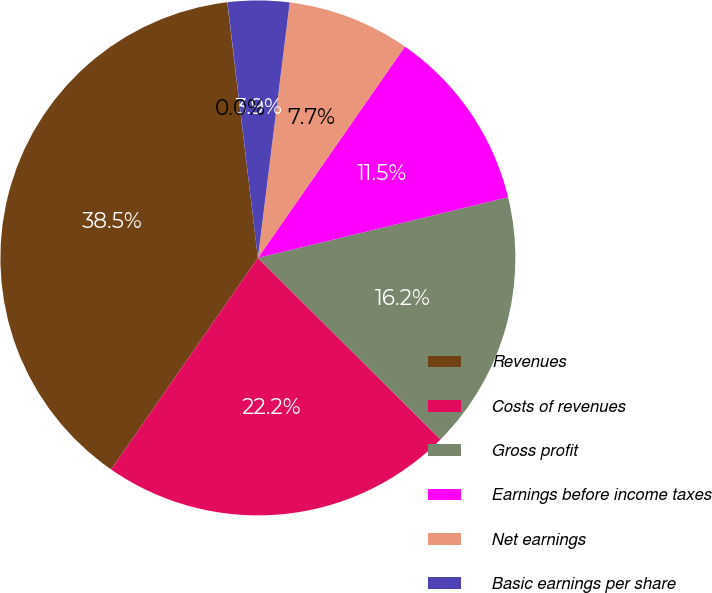Convert chart. <chart><loc_0><loc_0><loc_500><loc_500><pie_chart><fcel>Revenues<fcel>Costs of revenues<fcel>Gross profit<fcel>Earnings before income taxes<fcel>Net earnings<fcel>Basic earnings per share<fcel>Diluted earnings per share<nl><fcel>38.45%<fcel>22.2%<fcel>16.24%<fcel>11.54%<fcel>7.7%<fcel>3.86%<fcel>0.01%<nl></chart> 